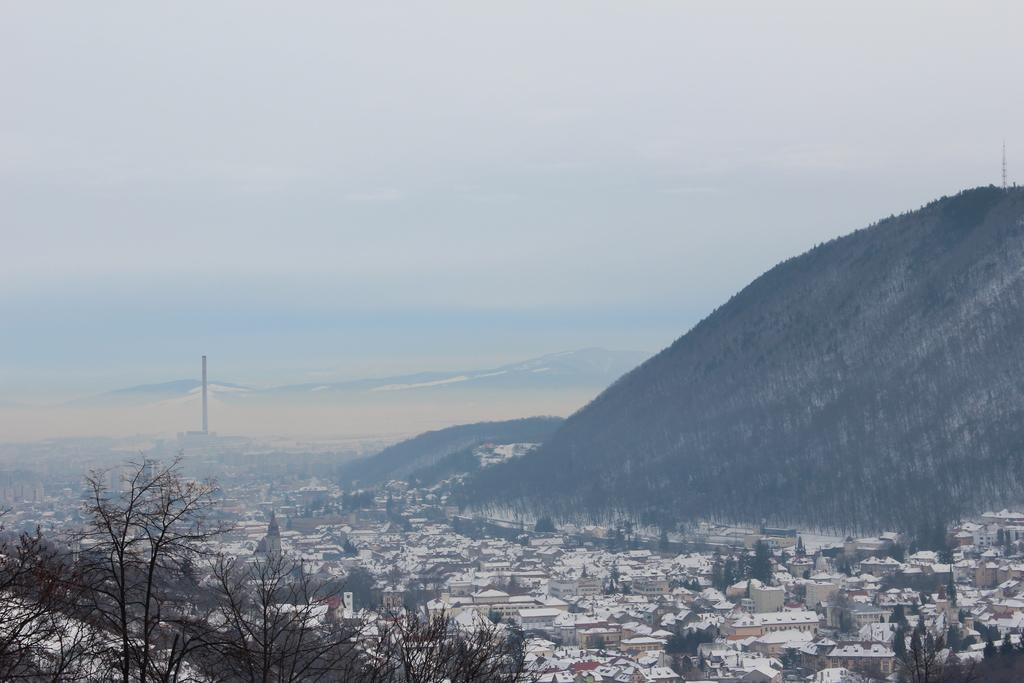What types of structures are located at the bottom of the image? There are houses and buildings at the bottom of the image. What else can be seen at the bottom of the image? There are trees at the bottom of the image. What is visible on the right side and in the background of the image? There are mountains on the right side and in the background of the image. What is visible at the top of the image? The sky is visible at the top of the image. Can you read the letters on the donkey in the image? There is no donkey present in the image, and therefore no letters to read. 